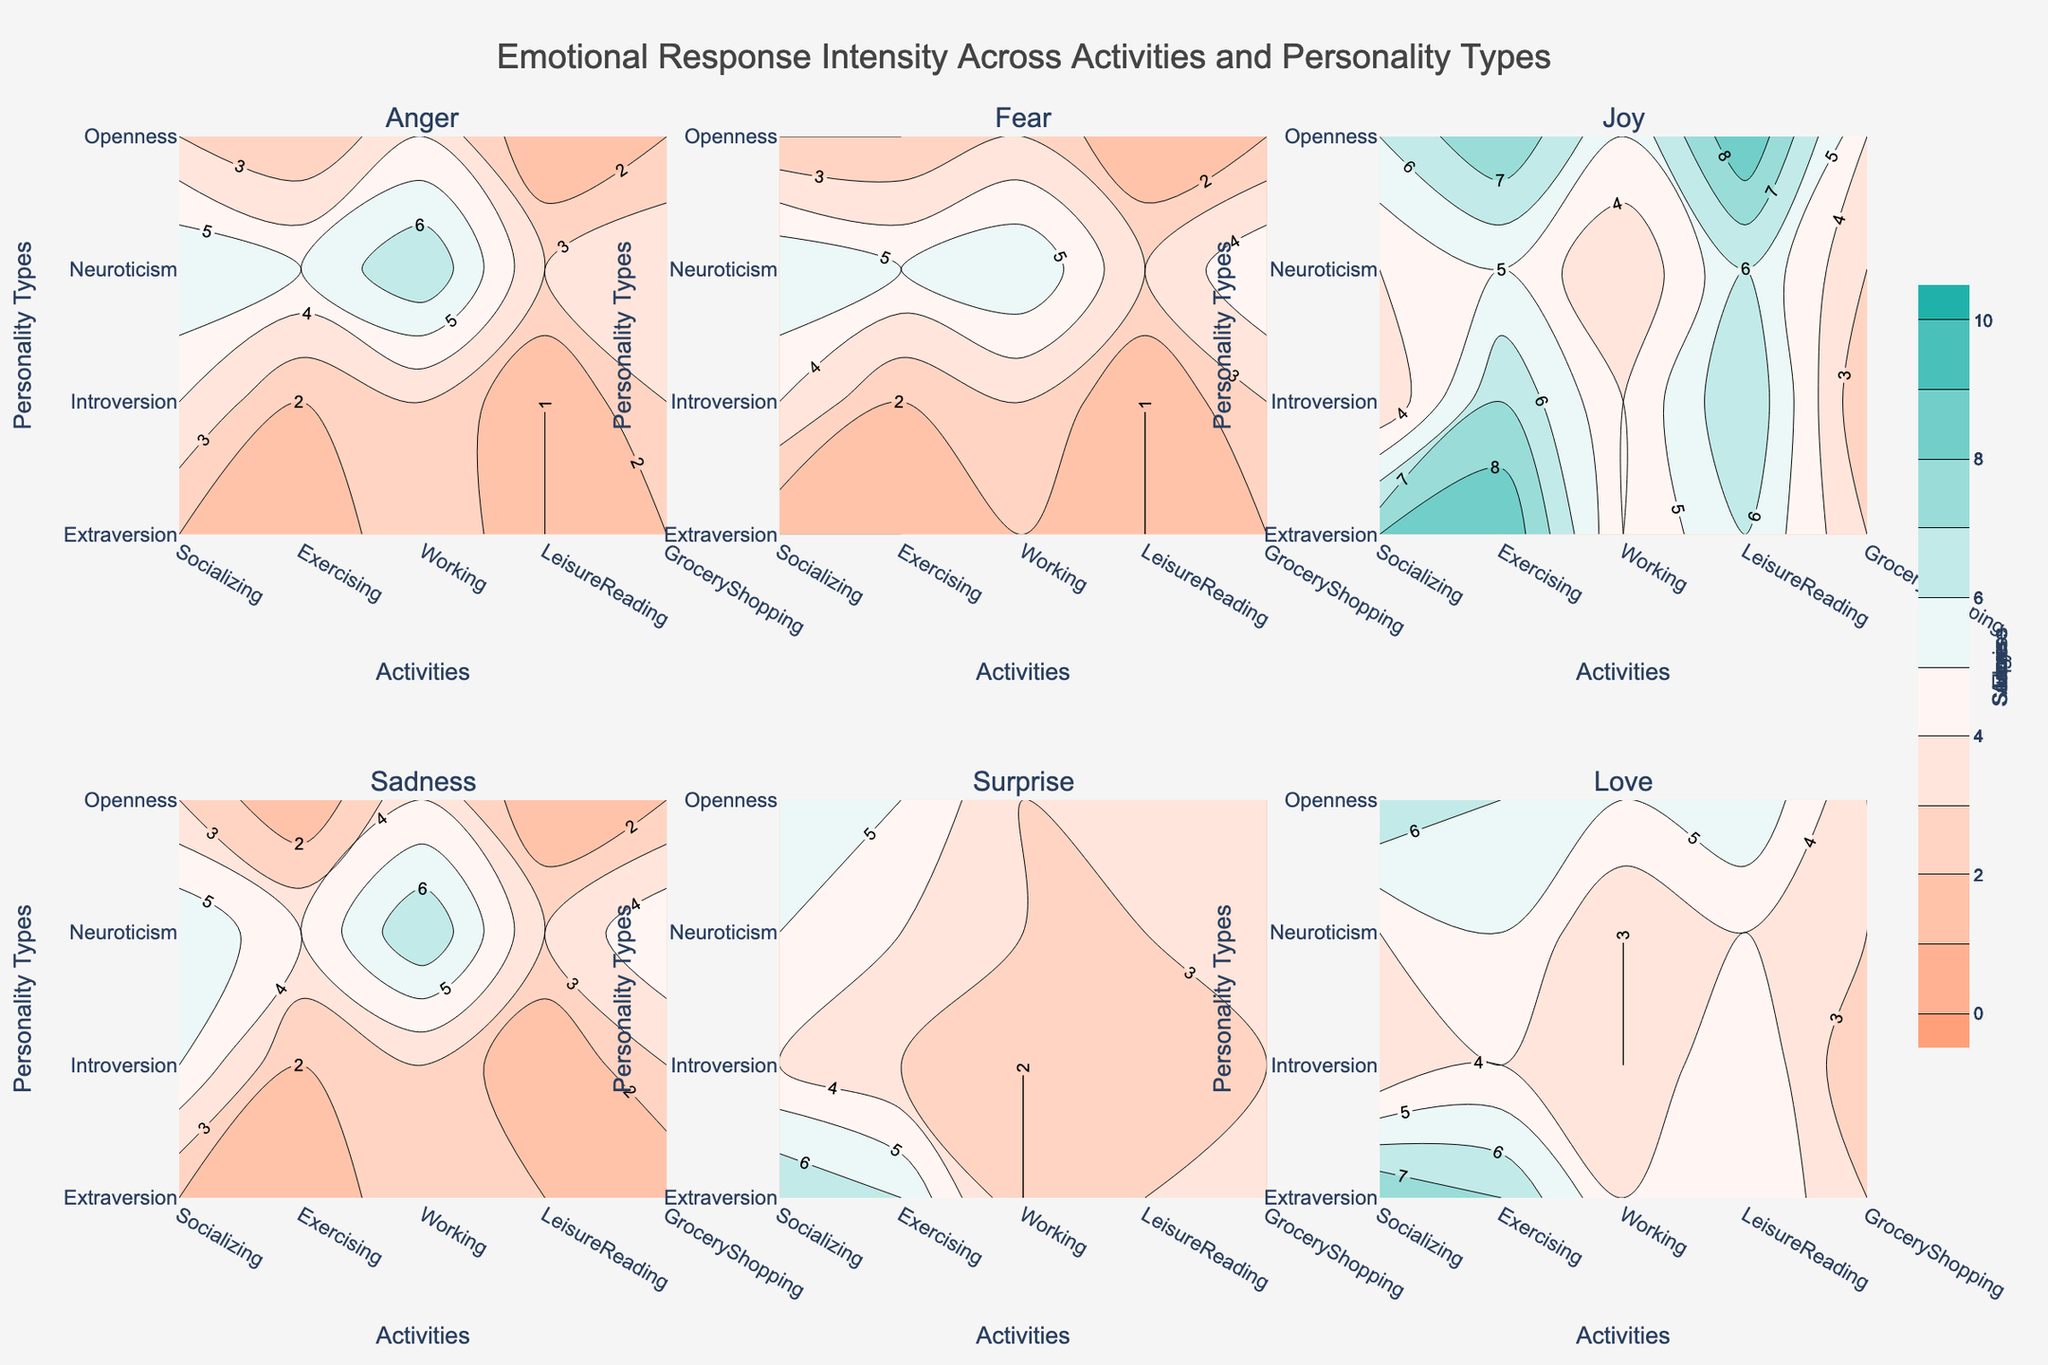What is the title of the figure? The title is typically found at the top of the figure and is used to describe the content or purpose of the plot. In this case, the title is "Emotional Response Intensity Across Activities and Personality Types".
Answer: Emotional Response Intensity Across Activities and Personality Types How many emotions are represented in the figure? By analyzing the subplot titles, we can count the different emotions depicted. In this case, the subplots are arranged as rows and columns, with each subplot titled with an emotion.
Answer: 6 Which activity and personality type combination shows the highest intensity of Joy? To answer this, look at the contour plots corresponding to 'Joy' and identify the highest contour value. By comparing across all activities and personality types, you can determine which combination has the highest intensity.
Answer: Exercising and Extraversion Which personality type experiences the most consistent levels of 'Fear' across different activities? To determine consistency, observe the contour plot for 'Fear' and look for the personality type whose contour values do not vary widely across different activities. Consistency means less variation across the plot.
Answer: Extraversion What is the emotional response of Introverts during Grocery Shopping in terms of 'Sadness'? For this, examine the contour plot for 'Sadness' and look at the value corresponding to the intersection of 'Introversion' and 'GroceryShopping'.
Answer: 3 Which emotion has the lowest intensity range across all activities and personality types? Analyze the range (difference between the highest and lowest values) for each emotion by looking at their contour plots. The smallest difference signifies the lowest intensity range.
Answer: Love Compare the 'Anger' levels of Extraverts and Neurotics during Working and provide the difference. For this, extract the contour values for 'Anger' at intersecting points of 'Extraversion', 'Neuroticism', and 'Working'. Compute the difference by subtracting the values.
Answer: 4 How does 'Surprise' vary between Exercising for Introverts and Extraverts? Examine the contour plot for 'Surprise' and note the values at the intersecting points for 'Exercising' with 'Introversion' and 'Extraversion'. Compare these values to infer the variation.
Answer: Higher for Extraversion What is the average 'Love' level for Opennes personality type across all activities? Sum the 'Love' values for 'Openness' across all activities and divide by the number of activities. This calculation provides the average level.
Answer: (7+6+5+6+3)/5 = 27/5 = 5.4 